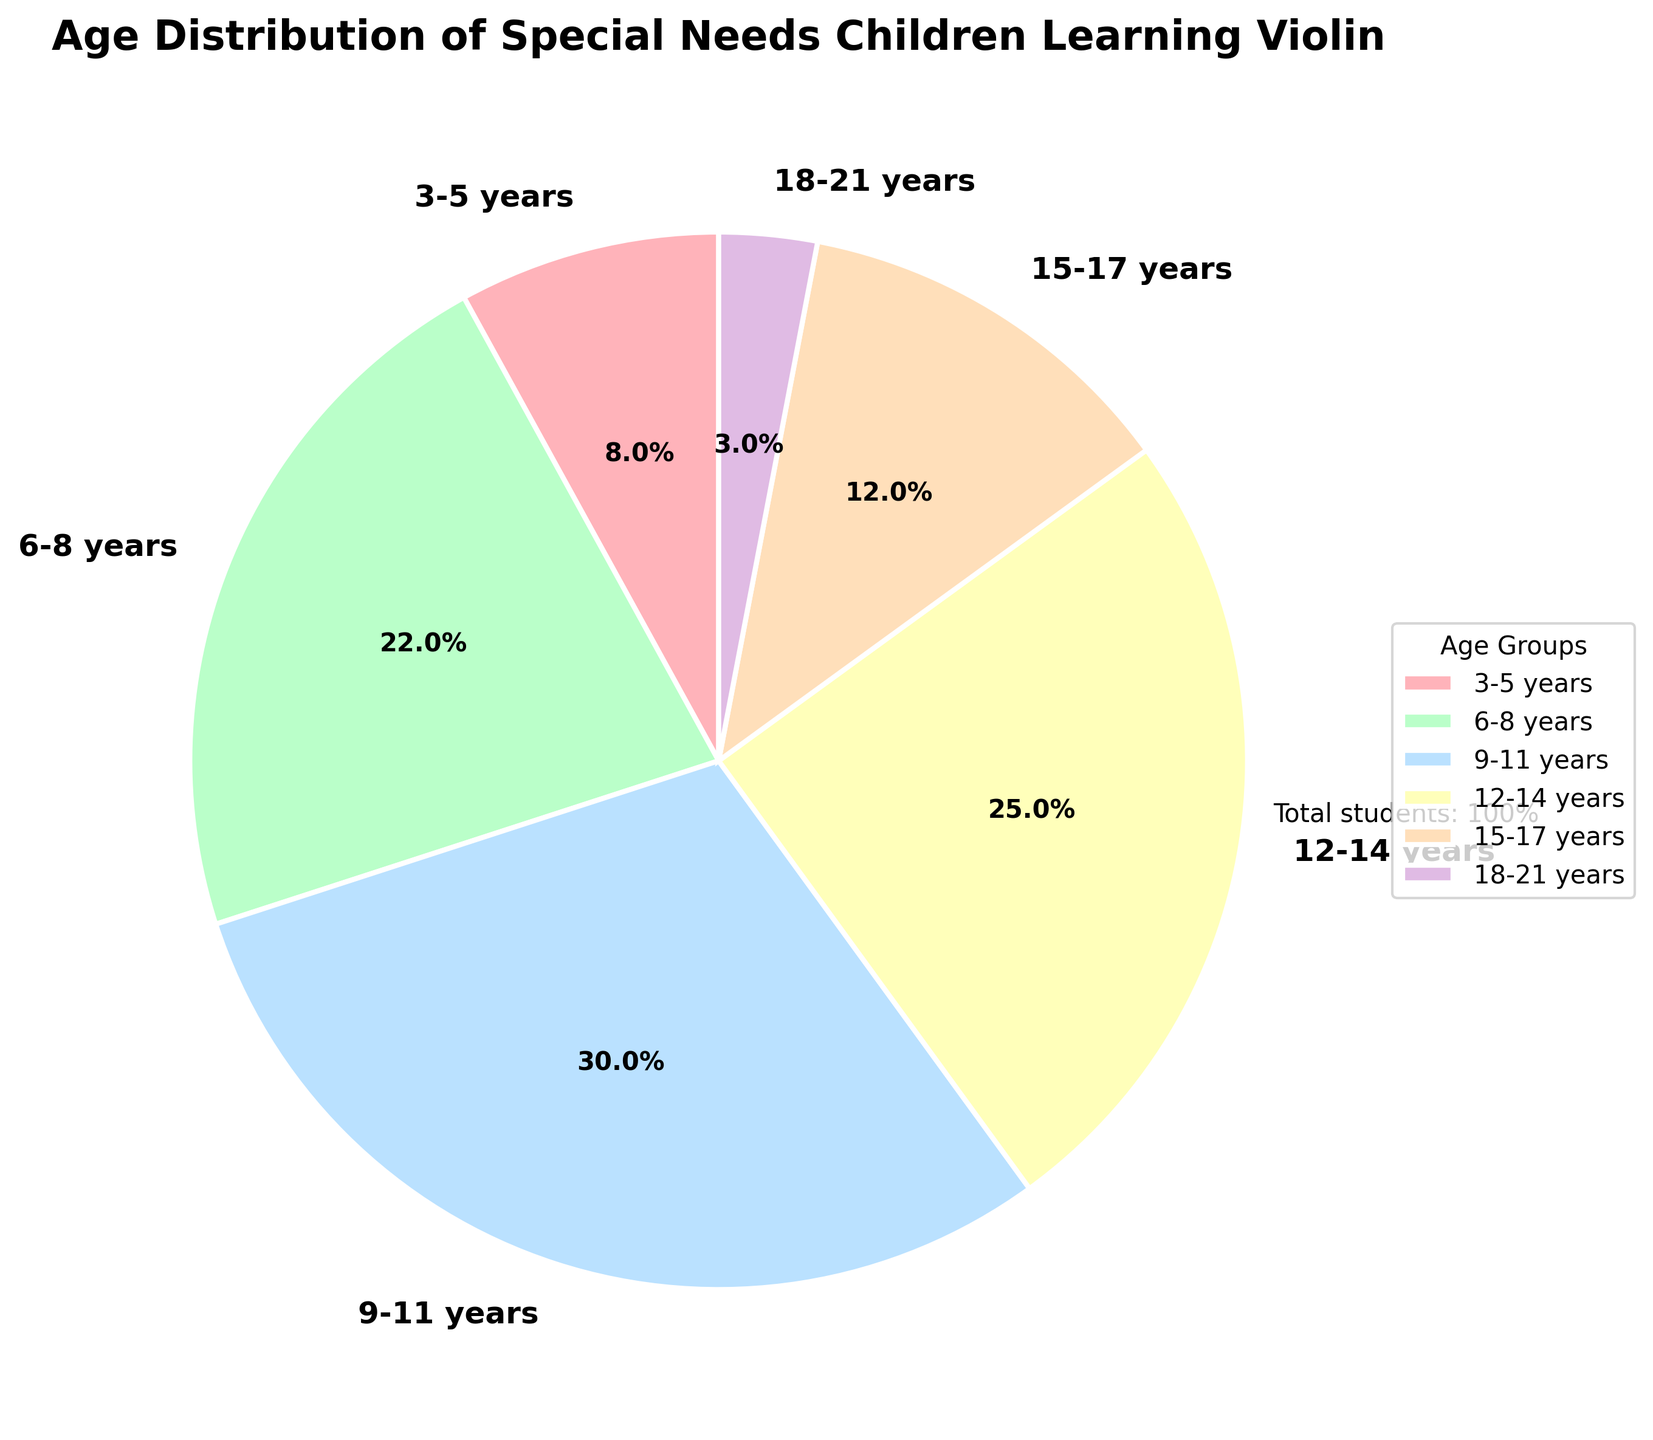What's the largest age group of special needs children learning violin? The age group with the highest percentage value is the largest. Here, the 9-11 years group has the highest percentage at 30%.
Answer: 9-11 years Which age group has the smallest representation in the pie chart? The age group with the lowest percentage value is the smallest. The 18-21 years group has the smallest representation at 3%.
Answer: 18-21 years How many age groups have a percentage greater than 20%? Identify the age groups with a percentage value over 20%. The 6-8 years, 9-11 years, and 12-14 years groups each have a percentage greater than 20%, making it three groups.
Answer: 3 What's the combined percentage of children aged between 6 and 14 years? Sum the percentage values of the 6-8 years, 9-11 years, and 12-14 years groups. The calculation is 22% (6-8 years) + 30% (9-11 years) + 25% (12-14 years), totaling 77%.
Answer: 77% Is the number of children aged 15-17 years greater than the number of children aged 3-5 years? Compare the percentages of the two age groups. The 15-17 years group has 12%, while the 3-5 years group has 8%. Therefore, there are more children aged 15-17 years than 3-5 years.
Answer: Yes Which age group has a percentage closest to the average percentage of all groups? First, calculate the average percentage: (8 + 22 + 30 + 25 + 12 + 3) / 6 = 16.67%. Then, compare the percentages to find the closest value. The 15-17 years group, with 12%, is the closest to the average.
Answer: 15-17 years How does the percentage of the 9-11 years group compare to the total percentage of children aged 15-21 years? Sum the percentages of the 15-17 years and 18-21 years groups: 12% + 3% = 15%. Compare it to the 9-11 years group at 30%, which is double the combined percentage of the 15-21 years groups.
Answer: Doubles Which age group is represented by the green color in the pie chart? Identify the age group corresponding to the green color in the pie chart. The green slice represents the 6-8 years group.
Answer: 6-8 years 